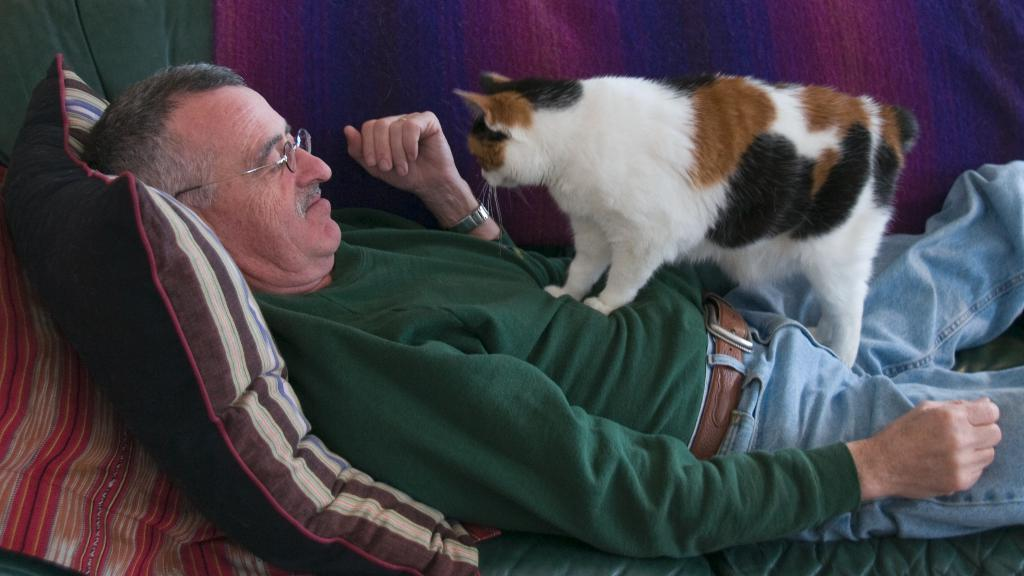What is the main subject of the image? The main subject of the image is a person lying on a cot. What is on top of the person? A cat is standing on the person's stomach. What is supporting the person's head? There is a pillow at the back of the person. What type of afterthought is the person having while lying on the cot? There is no indication of any thoughts or afterthoughts in the image, as it only shows a person lying on a cot with a cat on their stomach and a pillow behind their head. --- 